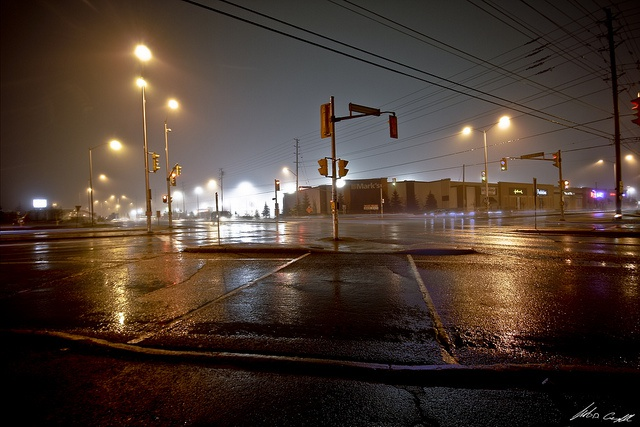Describe the objects in this image and their specific colors. I can see traffic light in black and maroon tones, traffic light in black, maroon, and olive tones, traffic light in black, maroon, and gray tones, traffic light in black, maroon, and darkgray tones, and traffic light in black, maroon, and gray tones in this image. 